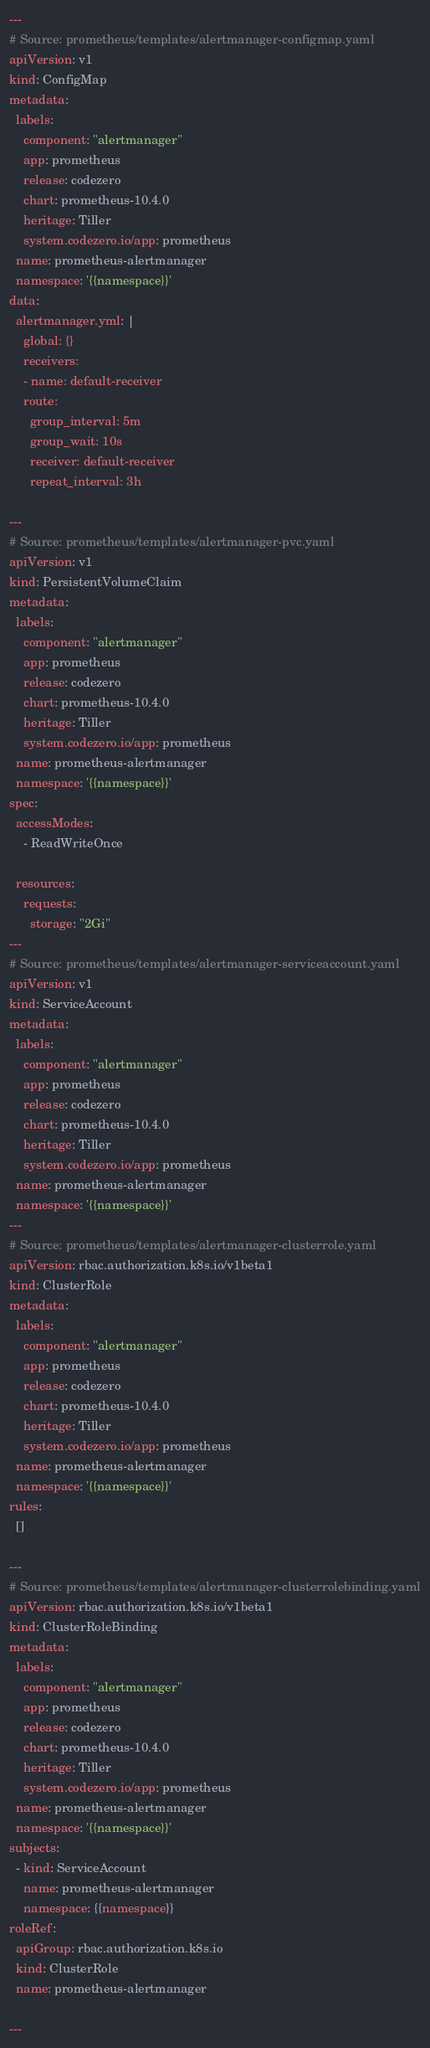<code> <loc_0><loc_0><loc_500><loc_500><_YAML_>---
# Source: prometheus/templates/alertmanager-configmap.yaml
apiVersion: v1
kind: ConfigMap
metadata:
  labels:
    component: "alertmanager"
    app: prometheus
    release: codezero
    chart: prometheus-10.4.0
    heritage: Tiller
    system.codezero.io/app: prometheus
  name: prometheus-alertmanager
  namespace: '{{namespace}}'
data:
  alertmanager.yml: |
    global: {}
    receivers:
    - name: default-receiver
    route:
      group_interval: 5m
      group_wait: 10s
      receiver: default-receiver
      repeat_interval: 3h

---
# Source: prometheus/templates/alertmanager-pvc.yaml
apiVersion: v1
kind: PersistentVolumeClaim
metadata:
  labels:
    component: "alertmanager"
    app: prometheus
    release: codezero
    chart: prometheus-10.4.0
    heritage: Tiller
    system.codezero.io/app: prometheus
  name: prometheus-alertmanager
  namespace: '{{namespace}}'
spec:
  accessModes:
    - ReadWriteOnce

  resources:
    requests:
      storage: "2Gi"
---
# Source: prometheus/templates/alertmanager-serviceaccount.yaml
apiVersion: v1
kind: ServiceAccount
metadata:
  labels:
    component: "alertmanager"
    app: prometheus
    release: codezero
    chart: prometheus-10.4.0
    heritage: Tiller
    system.codezero.io/app: prometheus
  name: prometheus-alertmanager
  namespace: '{{namespace}}'
---
# Source: prometheus/templates/alertmanager-clusterrole.yaml
apiVersion: rbac.authorization.k8s.io/v1beta1
kind: ClusterRole
metadata:
  labels:
    component: "alertmanager"
    app: prometheus
    release: codezero
    chart: prometheus-10.4.0
    heritage: Tiller
    system.codezero.io/app: prometheus
  name: prometheus-alertmanager
  namespace: '{{namespace}}'
rules:
  []

---
# Source: prometheus/templates/alertmanager-clusterrolebinding.yaml
apiVersion: rbac.authorization.k8s.io/v1beta1
kind: ClusterRoleBinding
metadata:
  labels:
    component: "alertmanager"
    app: prometheus
    release: codezero
    chart: prometheus-10.4.0
    heritage: Tiller
    system.codezero.io/app: prometheus
  name: prometheus-alertmanager
  namespace: '{{namespace}}'
subjects:
  - kind: ServiceAccount
    name: prometheus-alertmanager
    namespace: {{namespace}}
roleRef:
  apiGroup: rbac.authorization.k8s.io
  kind: ClusterRole
  name: prometheus-alertmanager

---</code> 